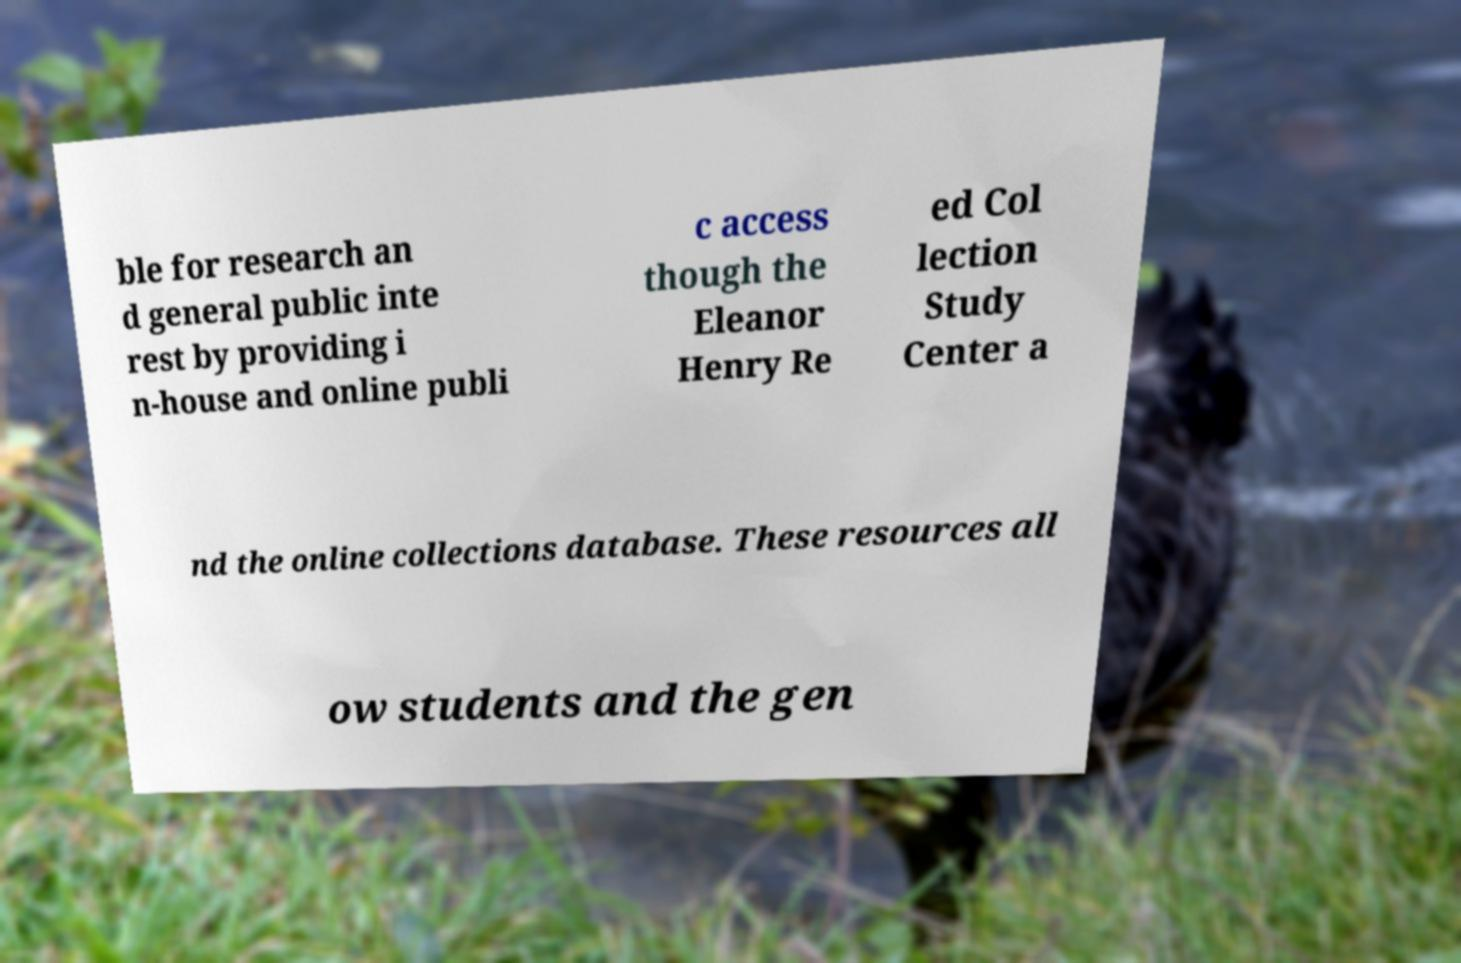Please identify and transcribe the text found in this image. ble for research an d general public inte rest by providing i n-house and online publi c access though the Eleanor Henry Re ed Col lection Study Center a nd the online collections database. These resources all ow students and the gen 